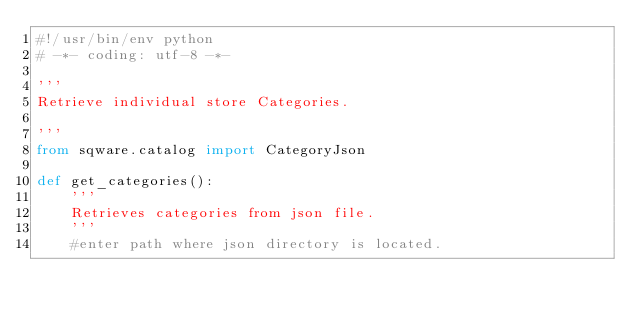<code> <loc_0><loc_0><loc_500><loc_500><_Python_>#!/usr/bin/env python
# -*- coding: utf-8 -*-

'''
Retrieve individual store Categories.

'''
from sqware.catalog import CategoryJson 

def get_categories():
	'''
	Retrieves categories from json file.
	'''
	#enter path where json directory is located.</code> 